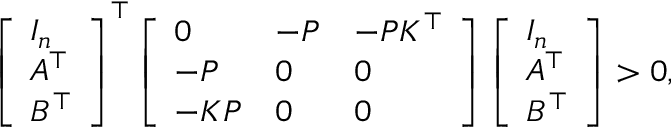<formula> <loc_0><loc_0><loc_500><loc_500>\left [ \begin{array} { l } { I _ { n } } \\ { A ^ { \top } } \\ { B ^ { \top } } \end{array} \right ] ^ { \top } \left [ \begin{array} { l l l } { 0 } & { - P } & { - P K ^ { \top } } \\ { - P } & { 0 } & { 0 } \\ { - K P } & { 0 } & { 0 } \end{array} \right ] \left [ \begin{array} { l } { I _ { n } } \\ { A ^ { \top } } \\ { B ^ { \top } } \end{array} \right ] > 0 ,</formula> 